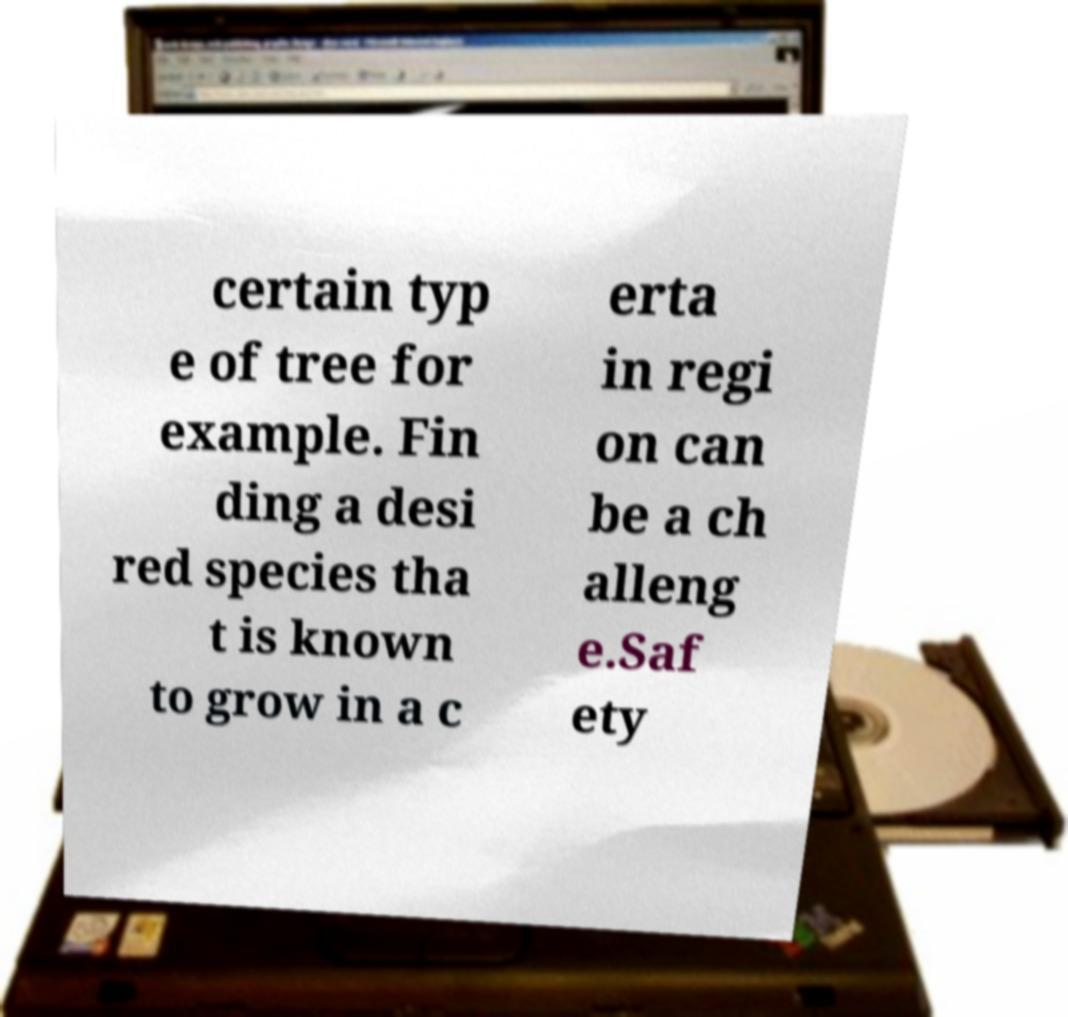There's text embedded in this image that I need extracted. Can you transcribe it verbatim? certain typ e of tree for example. Fin ding a desi red species tha t is known to grow in a c erta in regi on can be a ch alleng e.Saf ety 